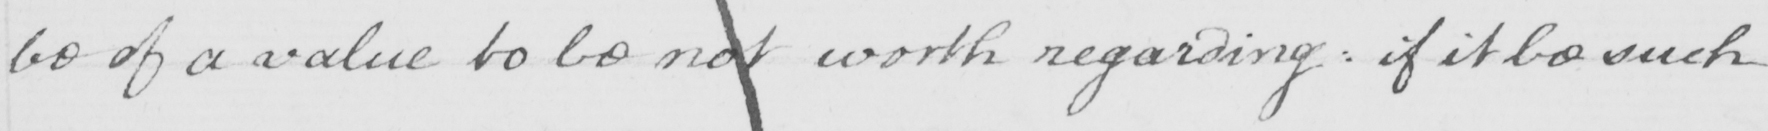Transcribe the text shown in this historical manuscript line. be of a value to be not worth regarding :  if it be such 